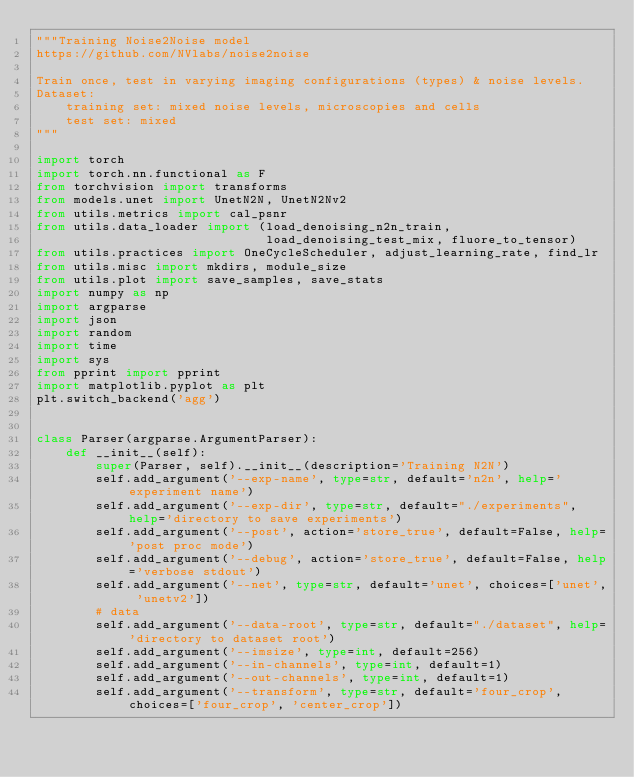<code> <loc_0><loc_0><loc_500><loc_500><_Python_>"""Training Noise2Noise model
https://github.com/NVlabs/noise2noise

Train once, test in varying imaging configurations (types) & noise levels.
Dataset: 
    training set: mixed noise levels, microscopies and cells
    test set: mixed
"""

import torch
import torch.nn.functional as F
from torchvision import transforms
from models.unet import UnetN2N, UnetN2Nv2
from utils.metrics import cal_psnr
from utils.data_loader import (load_denoising_n2n_train, 
                               load_denoising_test_mix, fluore_to_tensor)
from utils.practices import OneCycleScheduler, adjust_learning_rate, find_lr
from utils.misc import mkdirs, module_size
from utils.plot import save_samples, save_stats
import numpy as np
import argparse
import json
import random
import time
import sys
from pprint import pprint
import matplotlib.pyplot as plt
plt.switch_backend('agg')


class Parser(argparse.ArgumentParser):
    def __init__(self):
        super(Parser, self).__init__(description='Training N2N')
        self.add_argument('--exp-name', type=str, default='n2n', help='experiment name')
        self.add_argument('--exp-dir', type=str, default="./experiments", help='directory to save experiments')        
        self.add_argument('--post', action='store_true', default=False, help='post proc mode')
        self.add_argument('--debug', action='store_true', default=False, help='verbose stdout')
        self.add_argument('--net', type=str, default='unet', choices=['unet', 'unetv2'])
        # data
        self.add_argument('--data-root', type=str, default="./dataset", help='directory to dataset root')
        self.add_argument('--imsize', type=int, default=256)
        self.add_argument('--in-channels', type=int, default=1)
        self.add_argument('--out-channels', type=int, default=1)
        self.add_argument('--transform', type=str, default='four_crop', choices=['four_crop', 'center_crop'])</code> 